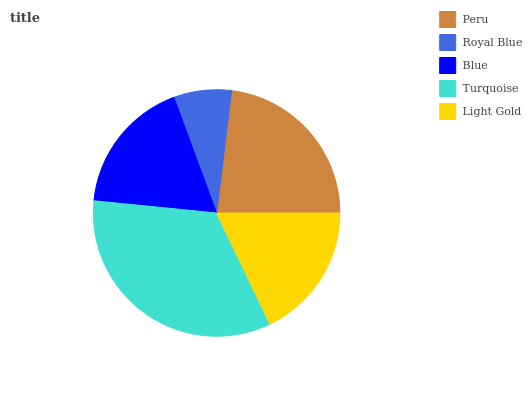Is Royal Blue the minimum?
Answer yes or no. Yes. Is Turquoise the maximum?
Answer yes or no. Yes. Is Blue the minimum?
Answer yes or no. No. Is Blue the maximum?
Answer yes or no. No. Is Blue greater than Royal Blue?
Answer yes or no. Yes. Is Royal Blue less than Blue?
Answer yes or no. Yes. Is Royal Blue greater than Blue?
Answer yes or no. No. Is Blue less than Royal Blue?
Answer yes or no. No. Is Light Gold the high median?
Answer yes or no. Yes. Is Light Gold the low median?
Answer yes or no. Yes. Is Royal Blue the high median?
Answer yes or no. No. Is Royal Blue the low median?
Answer yes or no. No. 